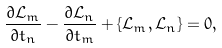Convert formula to latex. <formula><loc_0><loc_0><loc_500><loc_500>\frac { \partial \mathcal { L } _ { m } } { \partial t _ { n } } - \frac { \partial \mathcal { L } _ { n } } { \partial t _ { m } } + \{ \mathcal { L } _ { m } , \mathcal { L } _ { n } \} = 0 ,</formula> 